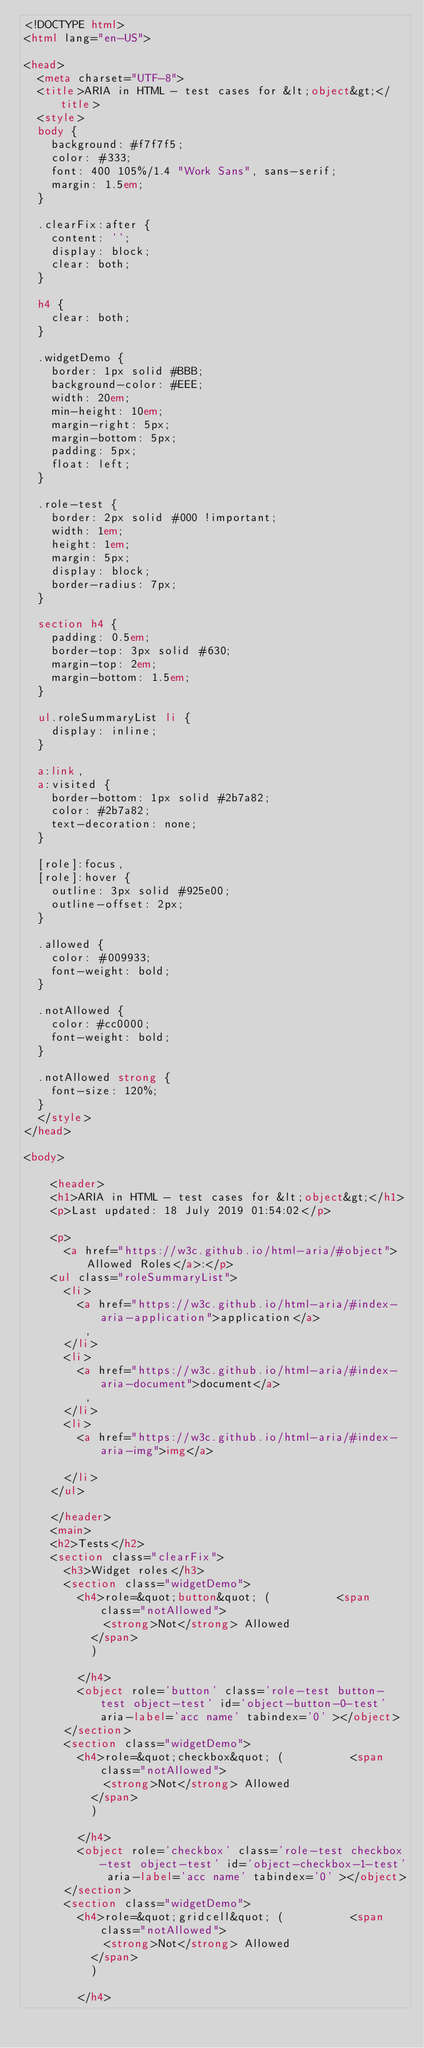<code> <loc_0><loc_0><loc_500><loc_500><_HTML_><!DOCTYPE html>
<html lang="en-US">

<head>
  <meta charset="UTF-8">
  <title>ARIA in HTML - test cases for &lt;object&gt;</title>
  <style>
  body {
    background: #f7f7f5;
    color: #333;
    font: 400 105%/1.4 "Work Sans", sans-serif;
    margin: 1.5em;
  }

  .clearFix:after {
    content: '';
    display: block;
    clear: both;
  }

  h4 {
    clear: both;
  }

  .widgetDemo {
    border: 1px solid #BBB;
    background-color: #EEE;
    width: 20em;
    min-height: 10em;
    margin-right: 5px;
    margin-bottom: 5px;
    padding: 5px;
    float: left;
  }

  .role-test {
    border: 2px solid #000 !important;
    width: 1em;
    height: 1em;
    margin: 5px;
    display: block;
    border-radius: 7px;
  }

  section h4 {
    padding: 0.5em;
    border-top: 3px solid #630;
    margin-top: 2em;
    margin-bottom: 1.5em;
  }

  ul.roleSummaryList li {
    display: inline;
  }

  a:link,
  a:visited {
    border-bottom: 1px solid #2b7a82;
    color: #2b7a82;
    text-decoration: none;
  }

  [role]:focus,
  [role]:hover {
    outline: 3px solid #925e00;
    outline-offset: 2px;
  }

  .allowed {
    color: #009933;
    font-weight: bold;
  }

  .notAllowed {
    color: #cc0000;
    font-weight: bold;
  }

  .notAllowed strong {
    font-size: 120%;
  }
  </style>
</head>

<body>
  
    <header>
    <h1>ARIA in HTML - test cases for &lt;object&gt;</h1>
    <p>Last updated: 18 July 2019 01:54:02</p>
     
    <p>
      <a href="https://w3c.github.io/html-aria/#object">Allowed Roles</a>:</p>
    <ul class="roleSummaryList">
      <li>
        <a href="https://w3c.github.io/html-aria/#index-aria-application">application</a>
         , 
      </li>
      <li>
        <a href="https://w3c.github.io/html-aria/#index-aria-document">document</a>
         , 
      </li>
      <li>
        <a href="https://w3c.github.io/html-aria/#index-aria-img">img</a>
        
      </li>
    </ul>
 
    </header>
    <main>
    <h2>Tests</h2>
    <section class="clearFix">
      <h3>Widget roles</h3>
      <section class="widgetDemo">
        <h4>role=&quot;button&quot; (          <span class="notAllowed">
            <strong>Not</strong> Allowed
          </span>
          )
          
        </h4>
        <object role='button' class='role-test button-test object-test' id='object-button-0-test' aria-label='acc name' tabindex='0' ></object>
      </section>
      <section class="widgetDemo">
        <h4>role=&quot;checkbox&quot; (          <span class="notAllowed">
            <strong>Not</strong> Allowed
          </span>
          )
          
        </h4>
        <object role='checkbox' class='role-test checkbox-test object-test' id='object-checkbox-1-test' aria-label='acc name' tabindex='0' ></object>
      </section>
      <section class="widgetDemo">
        <h4>role=&quot;gridcell&quot; (          <span class="notAllowed">
            <strong>Not</strong> Allowed
          </span>
          )
          
        </h4></code> 